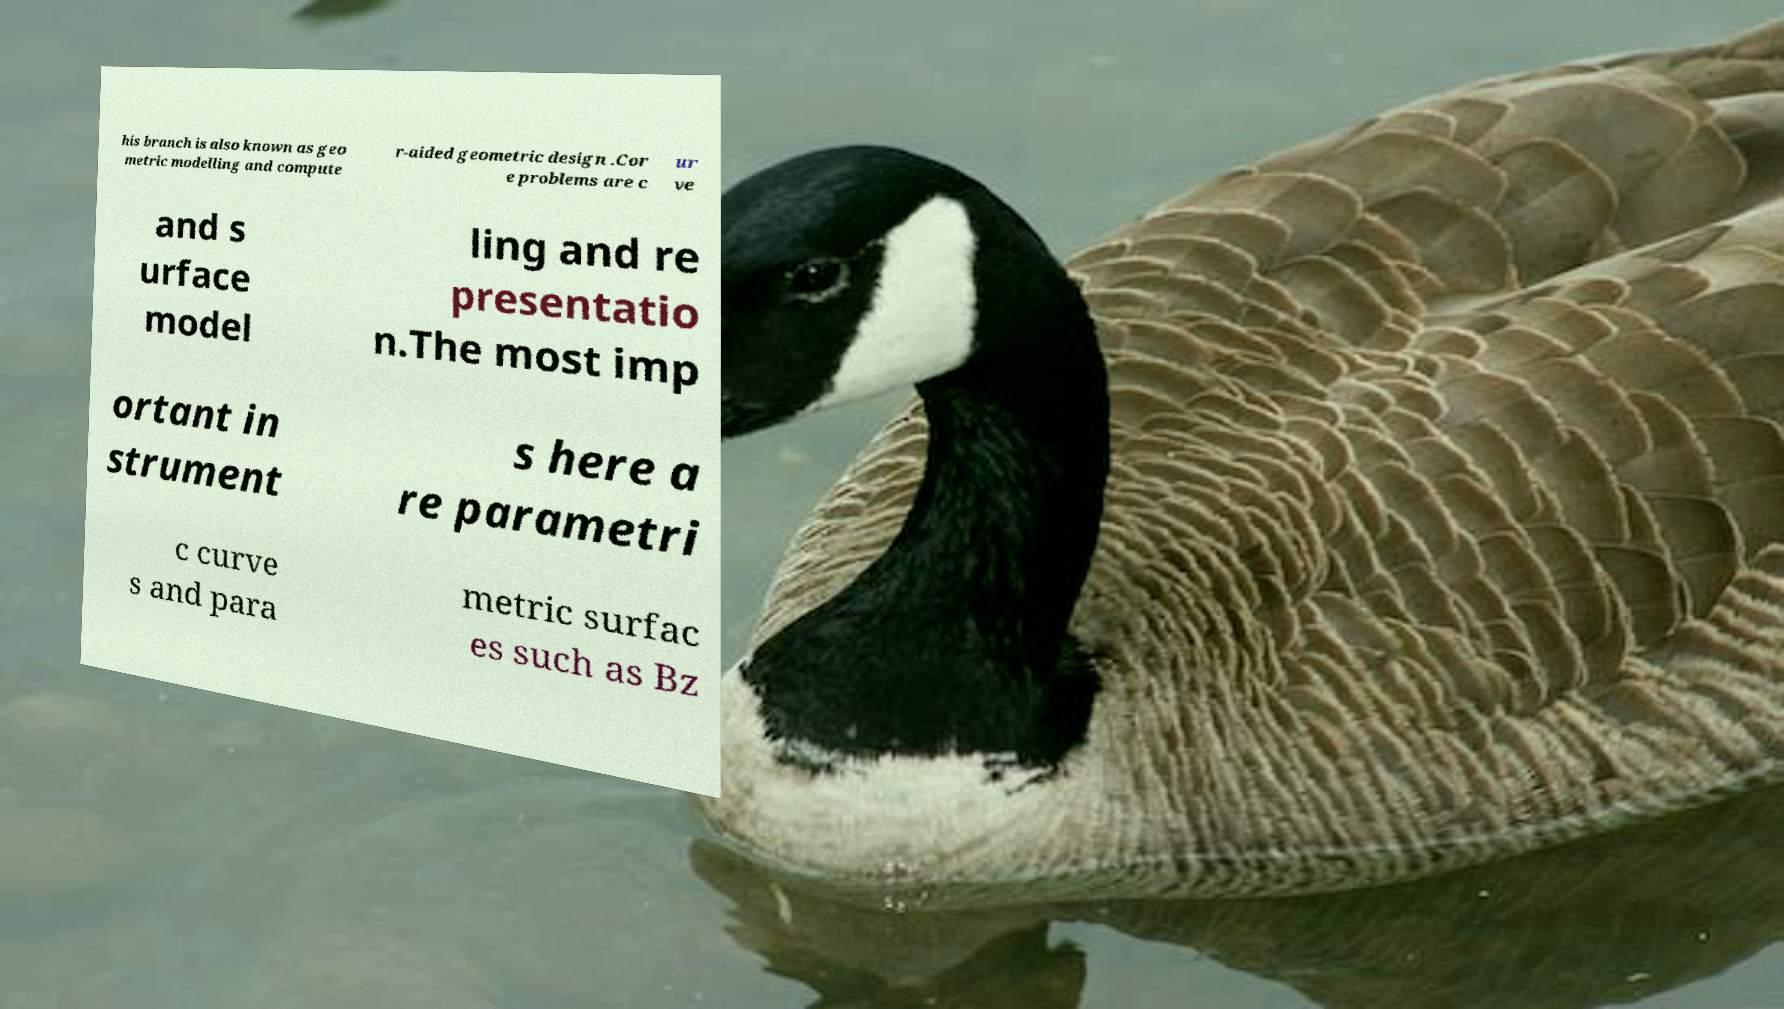What messages or text are displayed in this image? I need them in a readable, typed format. his branch is also known as geo metric modelling and compute r-aided geometric design .Cor e problems are c ur ve and s urface model ling and re presentatio n.The most imp ortant in strument s here a re parametri c curve s and para metric surfac es such as Bz 